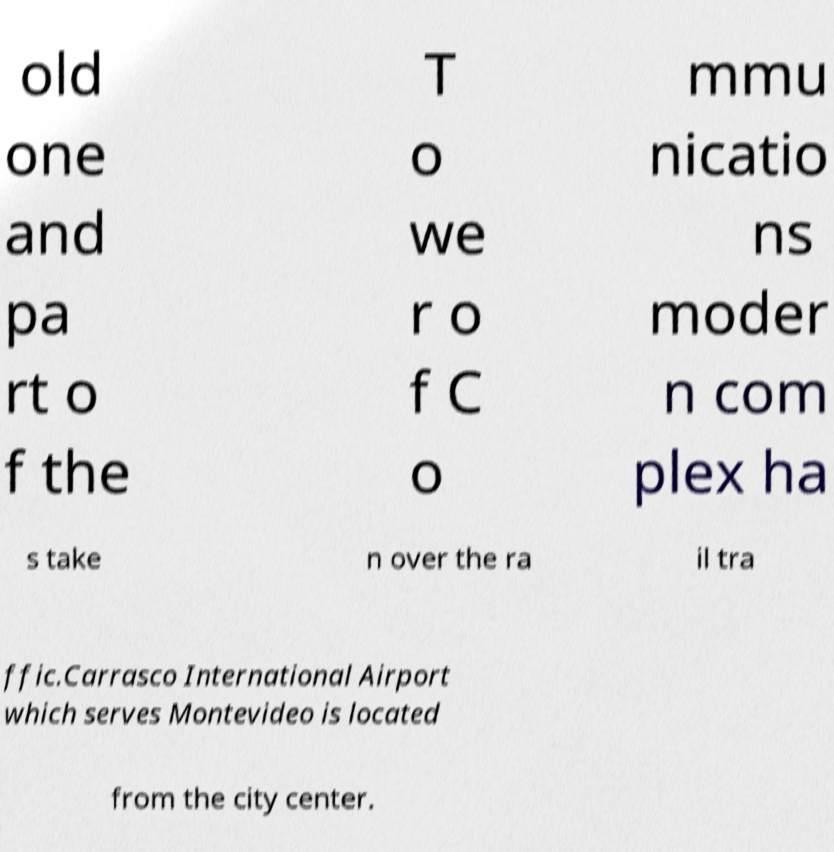Could you extract and type out the text from this image? old one and pa rt o f the T o we r o f C o mmu nicatio ns moder n com plex ha s take n over the ra il tra ffic.Carrasco International Airport which serves Montevideo is located from the city center. 